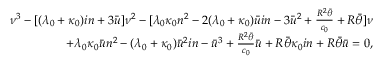Convert formula to latex. <formula><loc_0><loc_0><loc_500><loc_500>\begin{array} { r } { \nu ^ { 3 } - [ ( \lambda _ { 0 } + \kappa _ { 0 } ) i n + 3 \bar { u } ] \nu ^ { 2 } - [ \lambda _ { 0 } \kappa _ { 0 } n ^ { 2 } - 2 ( \lambda _ { 0 } + \kappa _ { 0 } ) \bar { u } i n - 3 \bar { u } ^ { 2 } + \frac { R ^ { 2 } \bar { \theta } } { c _ { 0 } } + R \bar { \theta } ] \nu } \\ { + \lambda _ { 0 } \kappa _ { 0 } \bar { u } n ^ { 2 } - ( \lambda _ { 0 } + \kappa _ { 0 } ) \bar { u } ^ { 2 } i n - \bar { u } ^ { 3 } + \frac { R ^ { 2 } \bar { \theta } } { c _ { 0 } } \bar { u } + R \bar { \theta } \kappa _ { 0 } i n + R \bar { \theta } \bar { u } = 0 , } \end{array}</formula> 